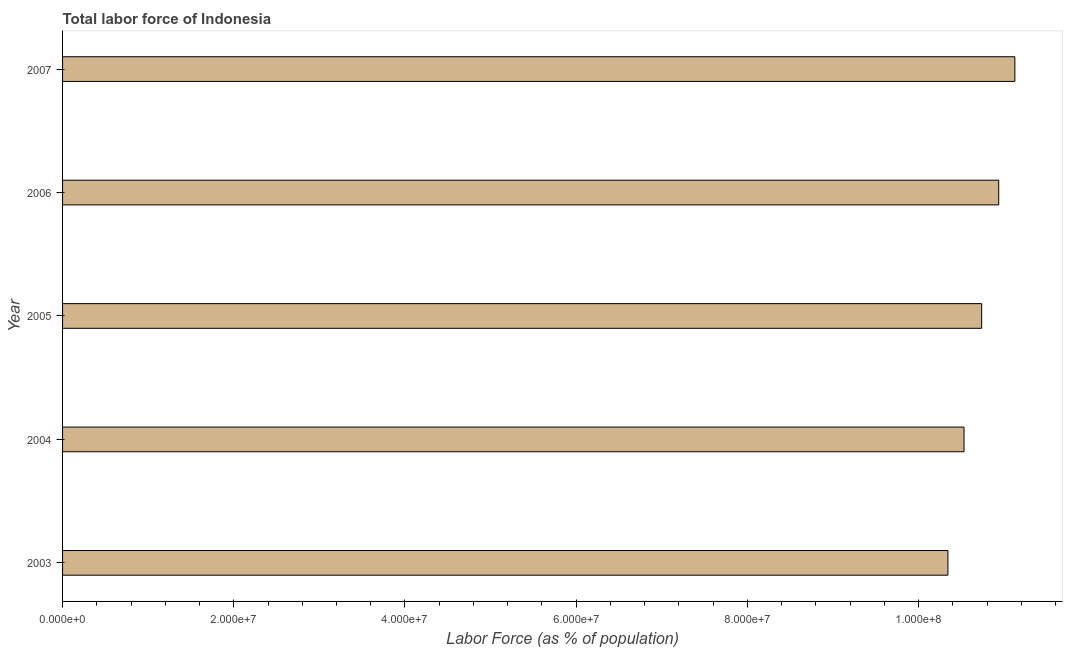What is the title of the graph?
Provide a short and direct response. Total labor force of Indonesia. What is the label or title of the X-axis?
Your answer should be compact. Labor Force (as % of population). What is the total labor force in 2007?
Your response must be concise. 1.11e+08. Across all years, what is the maximum total labor force?
Your answer should be compact. 1.11e+08. Across all years, what is the minimum total labor force?
Make the answer very short. 1.03e+08. In which year was the total labor force maximum?
Provide a succinct answer. 2007. In which year was the total labor force minimum?
Give a very brief answer. 2003. What is the sum of the total labor force?
Your response must be concise. 5.37e+08. What is the difference between the total labor force in 2003 and 2005?
Your answer should be compact. -3.94e+06. What is the average total labor force per year?
Ensure brevity in your answer.  1.07e+08. What is the median total labor force?
Your response must be concise. 1.07e+08. In how many years, is the total labor force greater than 4000000 %?
Give a very brief answer. 5. Do a majority of the years between 2003 and 2004 (inclusive) have total labor force greater than 76000000 %?
Ensure brevity in your answer.  Yes. What is the difference between the highest and the second highest total labor force?
Provide a short and direct response. 1.89e+06. What is the difference between the highest and the lowest total labor force?
Your answer should be compact. 7.82e+06. How many years are there in the graph?
Your response must be concise. 5. Are the values on the major ticks of X-axis written in scientific E-notation?
Your response must be concise. Yes. What is the Labor Force (as % of population) of 2003?
Make the answer very short. 1.03e+08. What is the Labor Force (as % of population) in 2004?
Offer a terse response. 1.05e+08. What is the Labor Force (as % of population) in 2005?
Your answer should be very brief. 1.07e+08. What is the Labor Force (as % of population) in 2006?
Offer a very short reply. 1.09e+08. What is the Labor Force (as % of population) in 2007?
Provide a short and direct response. 1.11e+08. What is the difference between the Labor Force (as % of population) in 2003 and 2004?
Offer a very short reply. -1.88e+06. What is the difference between the Labor Force (as % of population) in 2003 and 2005?
Provide a short and direct response. -3.94e+06. What is the difference between the Labor Force (as % of population) in 2003 and 2006?
Your answer should be very brief. -5.93e+06. What is the difference between the Labor Force (as % of population) in 2003 and 2007?
Make the answer very short. -7.82e+06. What is the difference between the Labor Force (as % of population) in 2004 and 2005?
Keep it short and to the point. -2.06e+06. What is the difference between the Labor Force (as % of population) in 2004 and 2006?
Your answer should be very brief. -4.05e+06. What is the difference between the Labor Force (as % of population) in 2004 and 2007?
Give a very brief answer. -5.94e+06. What is the difference between the Labor Force (as % of population) in 2005 and 2006?
Keep it short and to the point. -1.99e+06. What is the difference between the Labor Force (as % of population) in 2005 and 2007?
Make the answer very short. -3.88e+06. What is the difference between the Labor Force (as % of population) in 2006 and 2007?
Make the answer very short. -1.89e+06. What is the ratio of the Labor Force (as % of population) in 2003 to that in 2006?
Provide a short and direct response. 0.95. What is the ratio of the Labor Force (as % of population) in 2004 to that in 2005?
Keep it short and to the point. 0.98. What is the ratio of the Labor Force (as % of population) in 2004 to that in 2007?
Provide a short and direct response. 0.95. What is the ratio of the Labor Force (as % of population) in 2005 to that in 2007?
Provide a succinct answer. 0.96. 